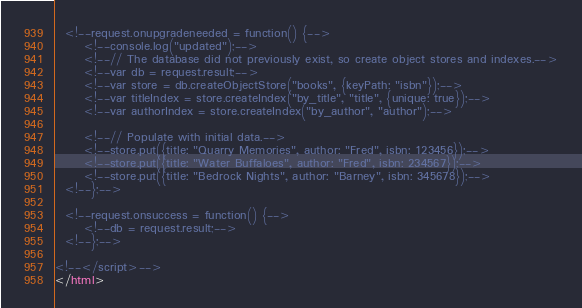Convert code to text. <code><loc_0><loc_0><loc_500><loc_500><_HTML_>
  <!--request.onupgradeneeded = function() {-->
      <!--console.log("updated");-->
      <!--// The database did not previously exist, so create object stores and indexes.-->
      <!--var db = request.result;-->
      <!--var store = db.createObjectStore("books", {keyPath: "isbn"});-->
      <!--var titleIndex = store.createIndex("by_title", "title", {unique: true});-->
      <!--var authorIndex = store.createIndex("by_author", "author");-->

      <!--// Populate with initial data.-->
      <!--store.put({title: "Quarry Memories", author: "Fred", isbn: 123456});-->
      <!--store.put({title: "Water Buffaloes", author: "Fred", isbn: 234567});-->
      <!--store.put({title: "Bedrock Nights", author: "Barney", isbn: 345678});-->
  <!--};-->

  <!--request.onsuccess = function() {-->
      <!--db = request.result;-->
  <!--};-->

<!--</script>-->
</html>
</code> 